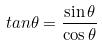<formula> <loc_0><loc_0><loc_500><loc_500>t a n \theta = \frac { \sin \theta } { \cos \theta }</formula> 